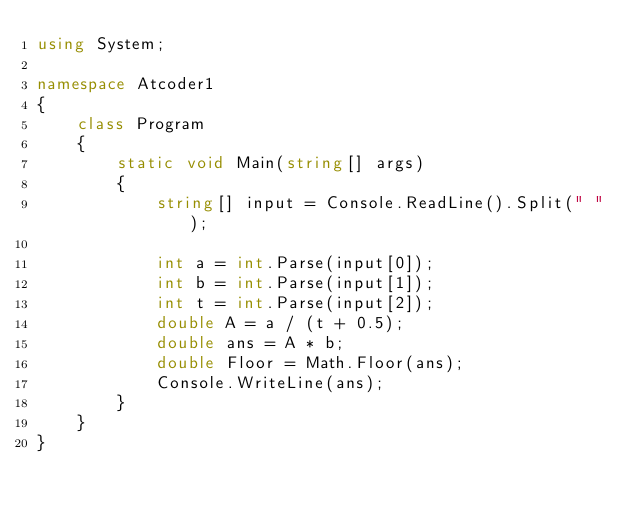<code> <loc_0><loc_0><loc_500><loc_500><_C#_>using System;

namespace Atcoder1
{
    class Program
    {
        static void Main(string[] args)
        {
            string[] input = Console.ReadLine().Split(" ");
            
            int a = int.Parse(input[0]);
            int b = int.Parse(input[1]);
            int t = int.Parse(input[2]);
            double A = a / (t + 0.5);
            double ans = A * b;
            double Floor = Math.Floor(ans);
            Console.WriteLine(ans);
        }
    }
}</code> 